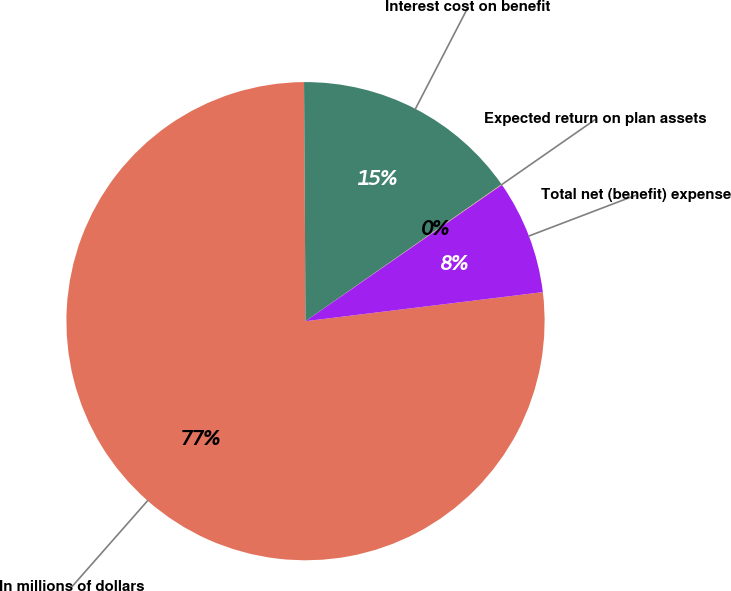<chart> <loc_0><loc_0><loc_500><loc_500><pie_chart><fcel>In millions of dollars<fcel>Interest cost on benefit<fcel>Expected return on plan assets<fcel>Total net (benefit) expense<nl><fcel>76.84%<fcel>15.4%<fcel>0.04%<fcel>7.72%<nl></chart> 